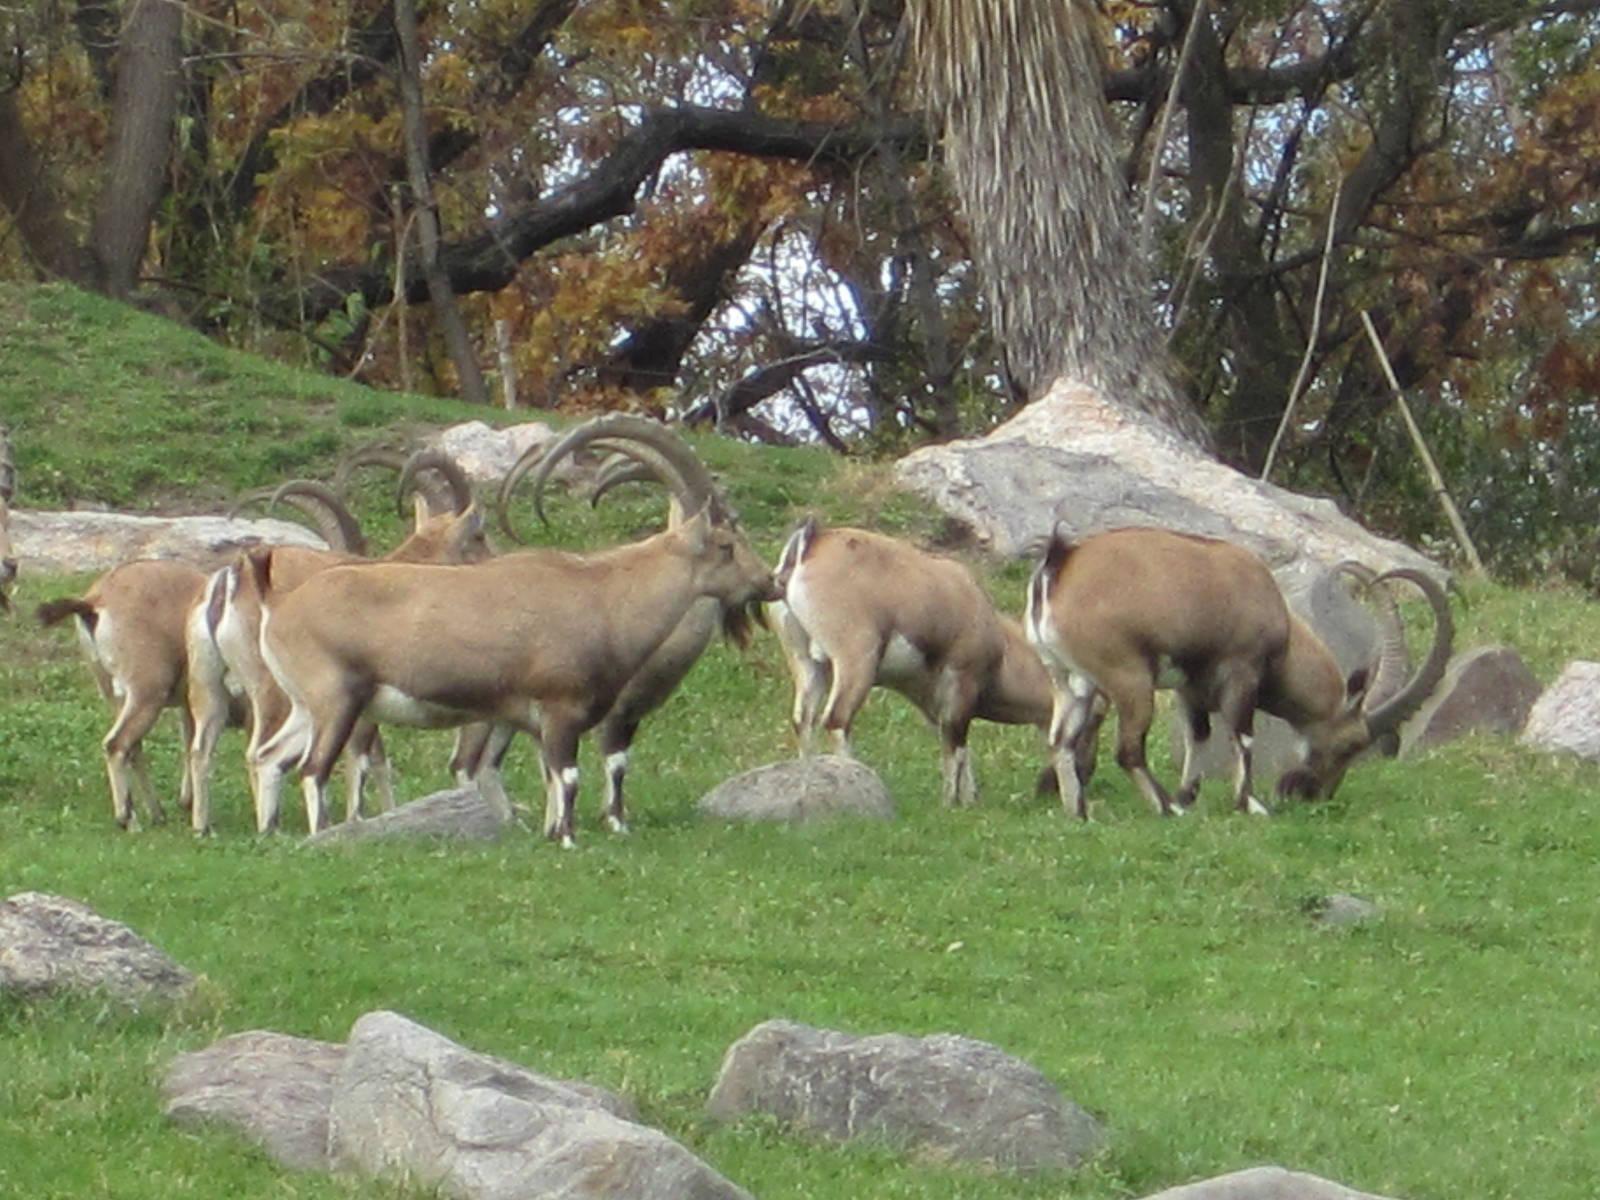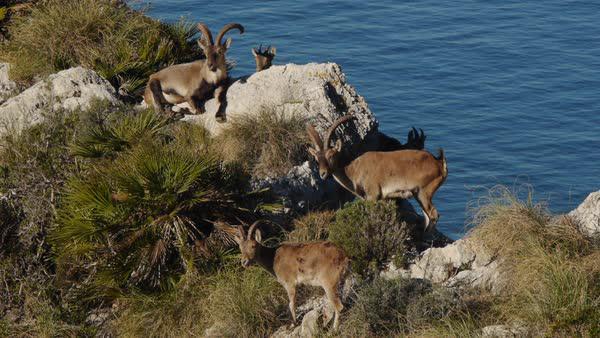The first image is the image on the left, the second image is the image on the right. Given the left and right images, does the statement "the animals in the image on the left are on grass" hold true? Answer yes or no. Yes. The first image is the image on the left, the second image is the image on the right. Given the left and right images, does the statement "The roof of a structure is visible in an image containing a horned goat." hold true? Answer yes or no. No. 